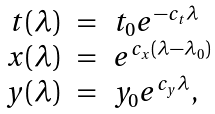<formula> <loc_0><loc_0><loc_500><loc_500>\begin{array} { r c l } t ( \lambda ) & = & t _ { 0 } e ^ { - c _ { t } \lambda } \\ x ( \lambda ) & = & e ^ { c _ { x } ( \lambda - \lambda _ { 0 } ) } \\ y ( \lambda ) & = & y _ { 0 } e ^ { c _ { y } \lambda } , \end{array}</formula> 